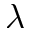Convert formula to latex. <formula><loc_0><loc_0><loc_500><loc_500>\lambda</formula> 